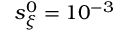<formula> <loc_0><loc_0><loc_500><loc_500>s _ { \xi } ^ { 0 } = 1 0 ^ { - 3 }</formula> 